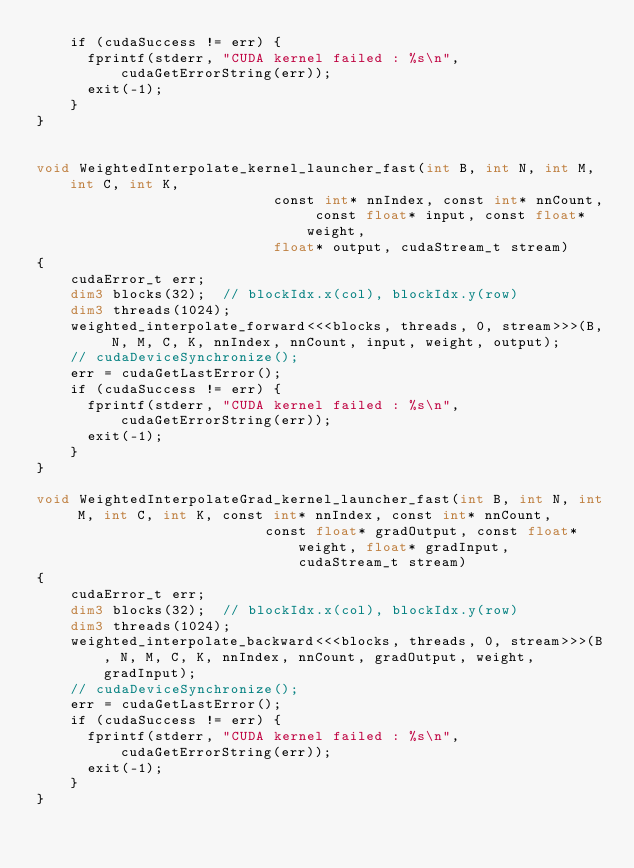Convert code to text. <code><loc_0><loc_0><loc_500><loc_500><_Cuda_>    if (cudaSuccess != err) {
      fprintf(stderr, "CUDA kernel failed : %s\n", cudaGetErrorString(err));
      exit(-1);
    }
}


void WeightedInterpolate_kernel_launcher_fast(int B, int N, int M, int C, int K, 
                            const int* nnIndex, const int* nnCount, const float* input, const float* weight,
                            float* output, cudaStream_t stream)
{ 
    cudaError_t err;
    dim3 blocks(32);  // blockIdx.x(col), blockIdx.y(row)
    dim3 threads(1024);
    weighted_interpolate_forward<<<blocks, threads, 0, stream>>>(B, N, M, C, K, nnIndex, nnCount, input, weight, output);
    // cudaDeviceSynchronize();
    err = cudaGetLastError();
    if (cudaSuccess != err) {
      fprintf(stderr, "CUDA kernel failed : %s\n", cudaGetErrorString(err));
      exit(-1);
    }
}

void WeightedInterpolateGrad_kernel_launcher_fast(int B, int N, int M, int C, int K, const int* nnIndex, const int* nnCount,
                           const float* gradOutput, const float* weight, float* gradInput, cudaStream_t stream)
{
    cudaError_t err;
    dim3 blocks(32);  // blockIdx.x(col), blockIdx.y(row)
    dim3 threads(1024);
    weighted_interpolate_backward<<<blocks, threads, 0, stream>>>(B, N, M, C, K, nnIndex, nnCount, gradOutput, weight, gradInput);
    // cudaDeviceSynchronize();
    err = cudaGetLastError();
    if (cudaSuccess != err) {
      fprintf(stderr, "CUDA kernel failed : %s\n", cudaGetErrorString(err));
      exit(-1);
    }
}</code> 